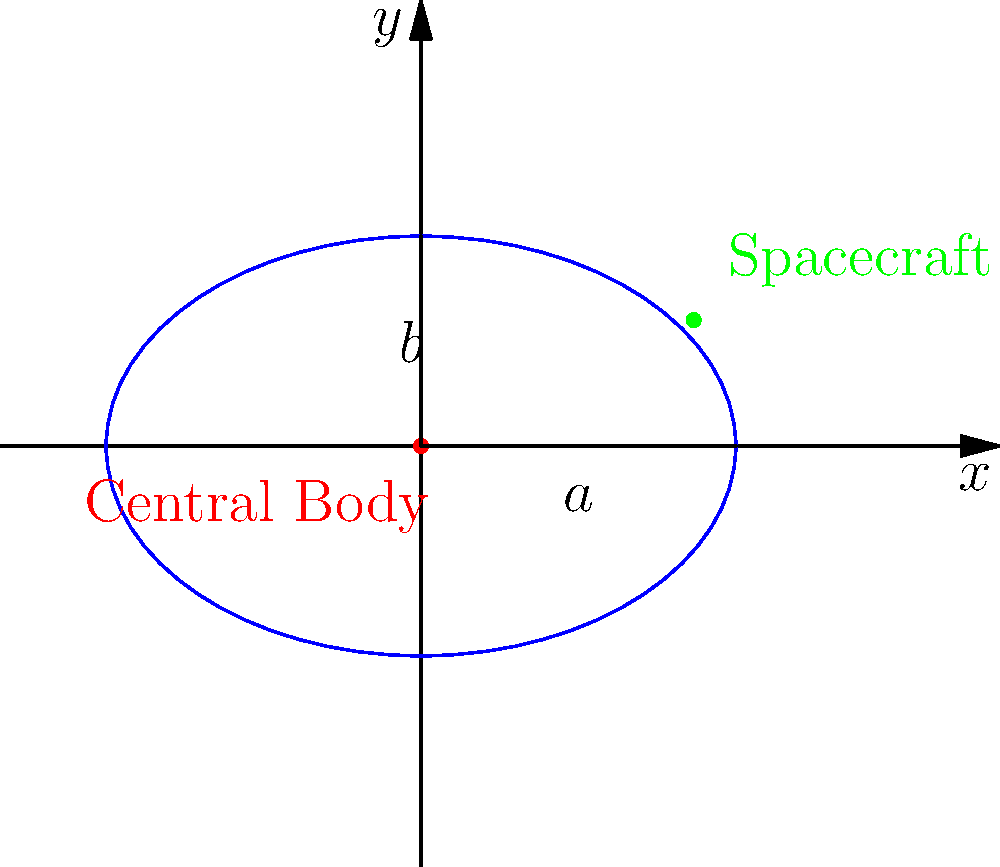As an innovative spacecraft designer, you're working on optimizing orbital trajectories. Consider a simplified two-body problem where a spacecraft orbits a central body in an elliptical orbit, as shown in the diagram. The semi-major axis $a$ is 1.5 units, and the semi-minor axis $b$ is 1 unit. What is the eccentricity $e$ of this orbit, rounded to three decimal places? To solve this problem, we'll follow these steps:

1) Recall the formula for eccentricity in terms of semi-major axis $a$ and semi-minor axis $b$:

   $$e = \sqrt{1 - \frac{b^2}{a^2}}$$

2) We're given:
   $a = 1.5$ units
   $b = 1$ unit

3) Substitute these values into the equation:

   $$e = \sqrt{1 - \frac{1^2}{1.5^2}}$$

4) Simplify inside the parentheses:

   $$e = \sqrt{1 - \frac{1}{2.25}}$$

5) Perform the division:

   $$e = \sqrt{1 - 0.4444...}$$

6) Subtract:

   $$e = \sqrt{0.5555...}$$

7) Take the square root:

   $$e \approx 0.7453...$$

8) Rounding to three decimal places:

   $$e \approx 0.745$$

This eccentricity indicates a moderately elliptical orbit, which is consistent with the diagram showing an ellipse that is noticeably elongated but not extremely so.
Answer: 0.745 